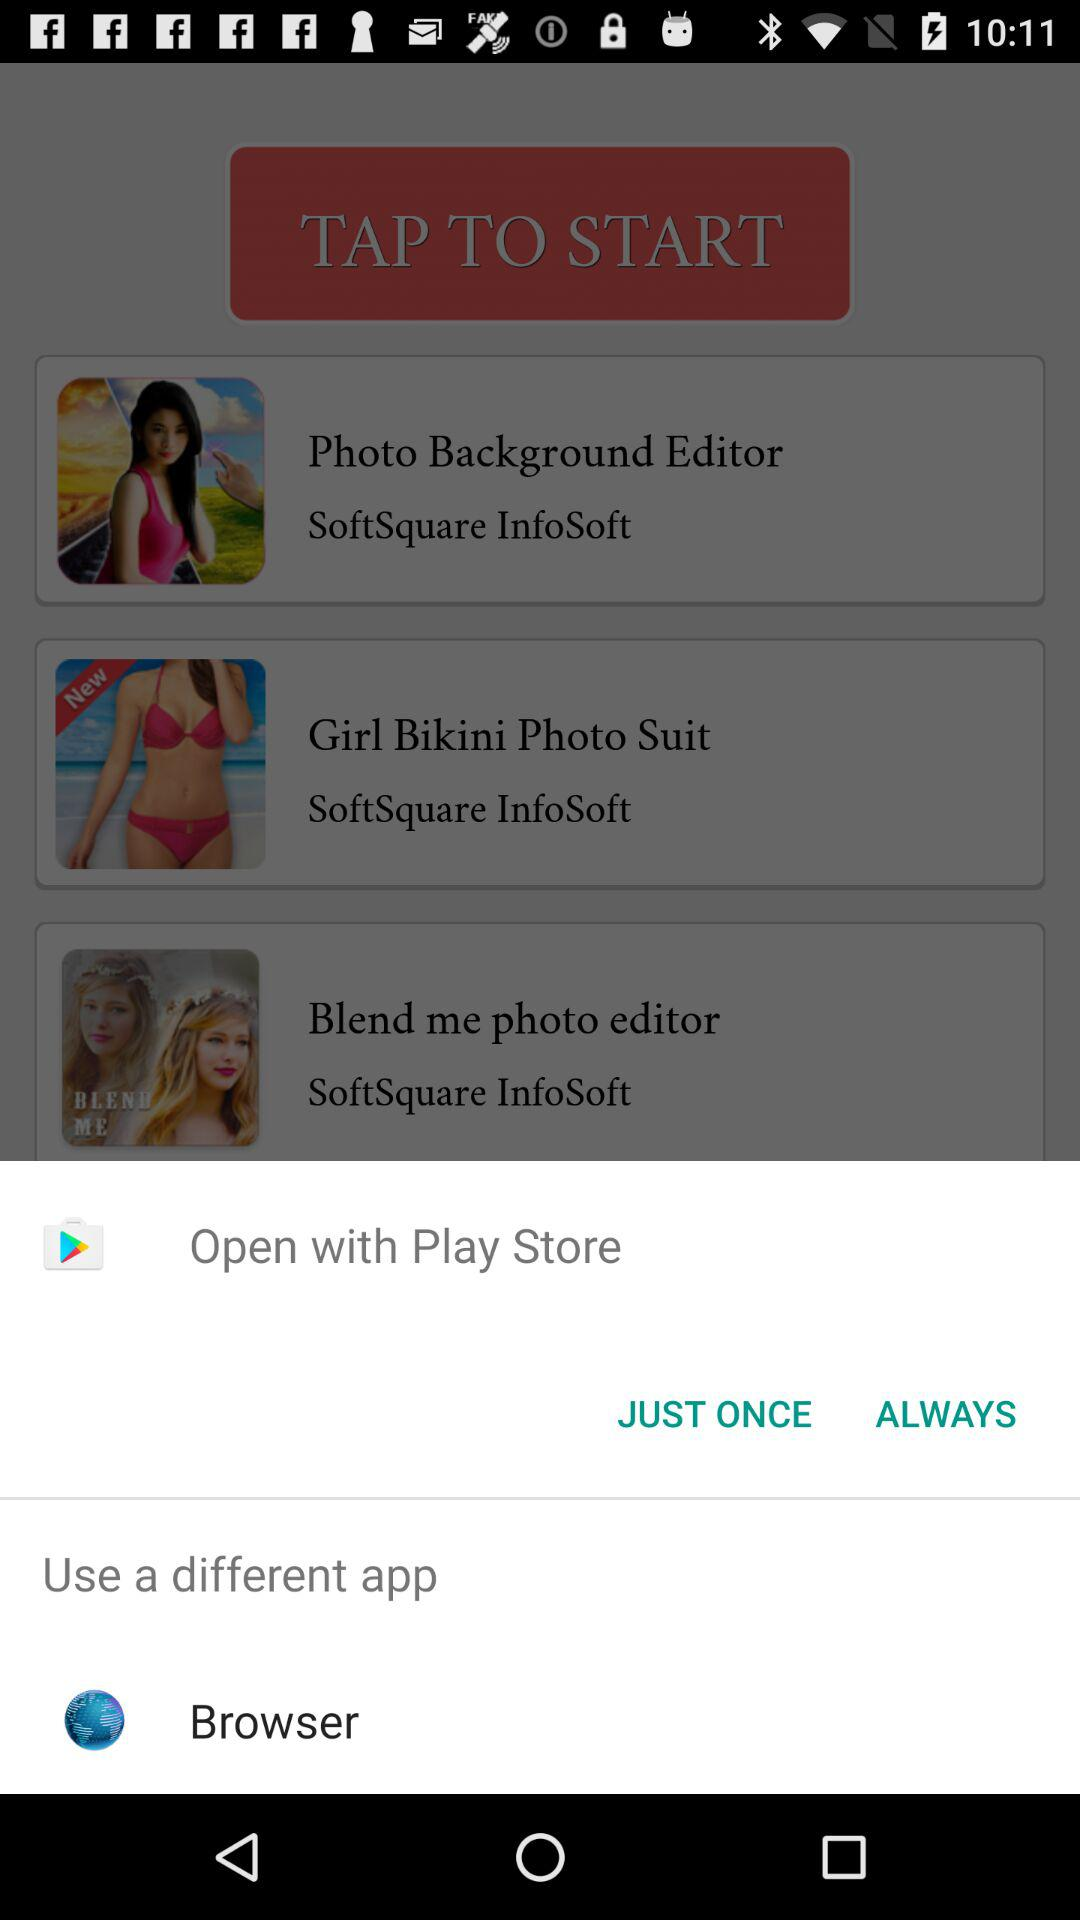How many apps are available for download?
Answer the question using a single word or phrase. 3 